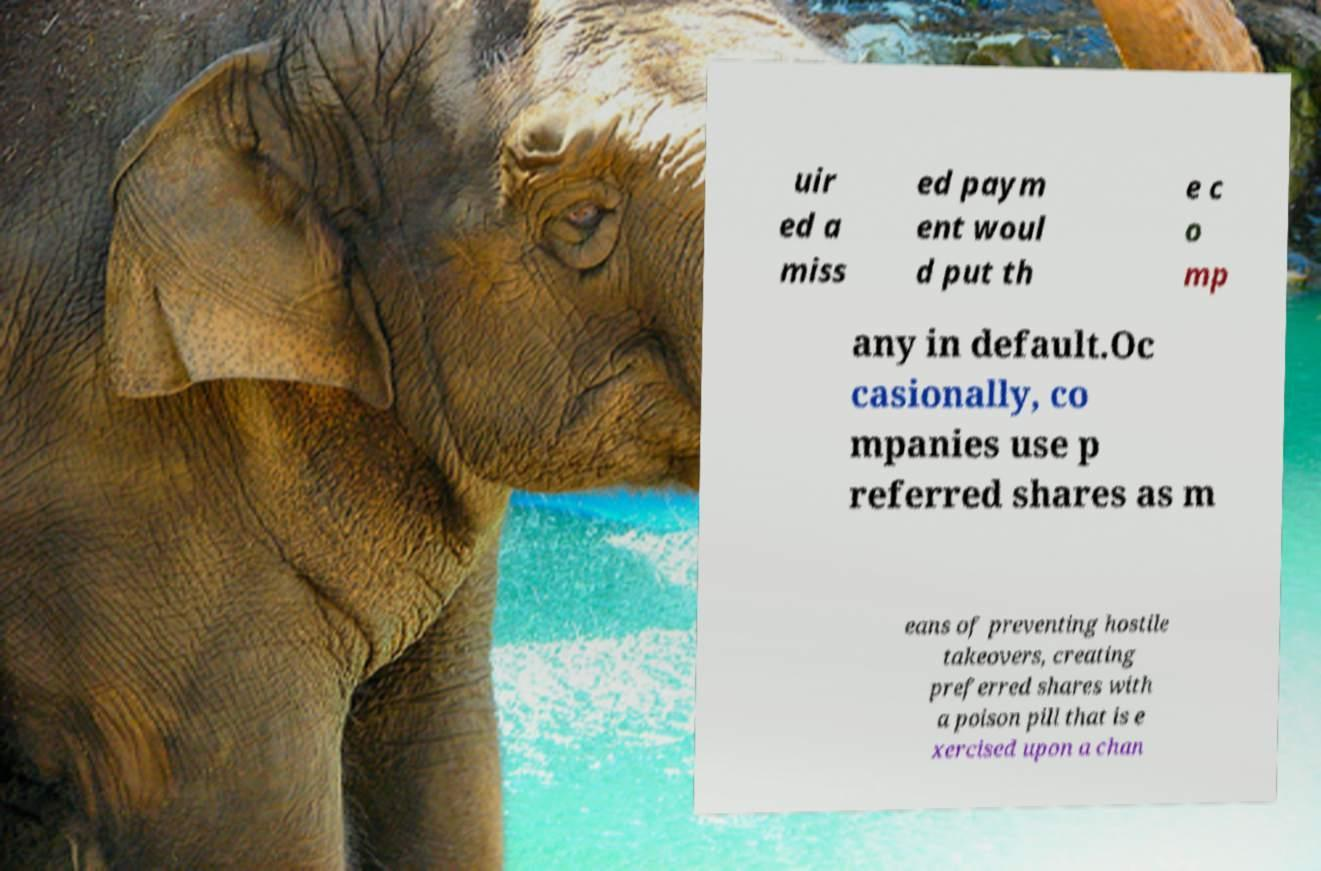Can you read and provide the text displayed in the image?This photo seems to have some interesting text. Can you extract and type it out for me? uir ed a miss ed paym ent woul d put th e c o mp any in default.Oc casionally, co mpanies use p referred shares as m eans of preventing hostile takeovers, creating preferred shares with a poison pill that is e xercised upon a chan 